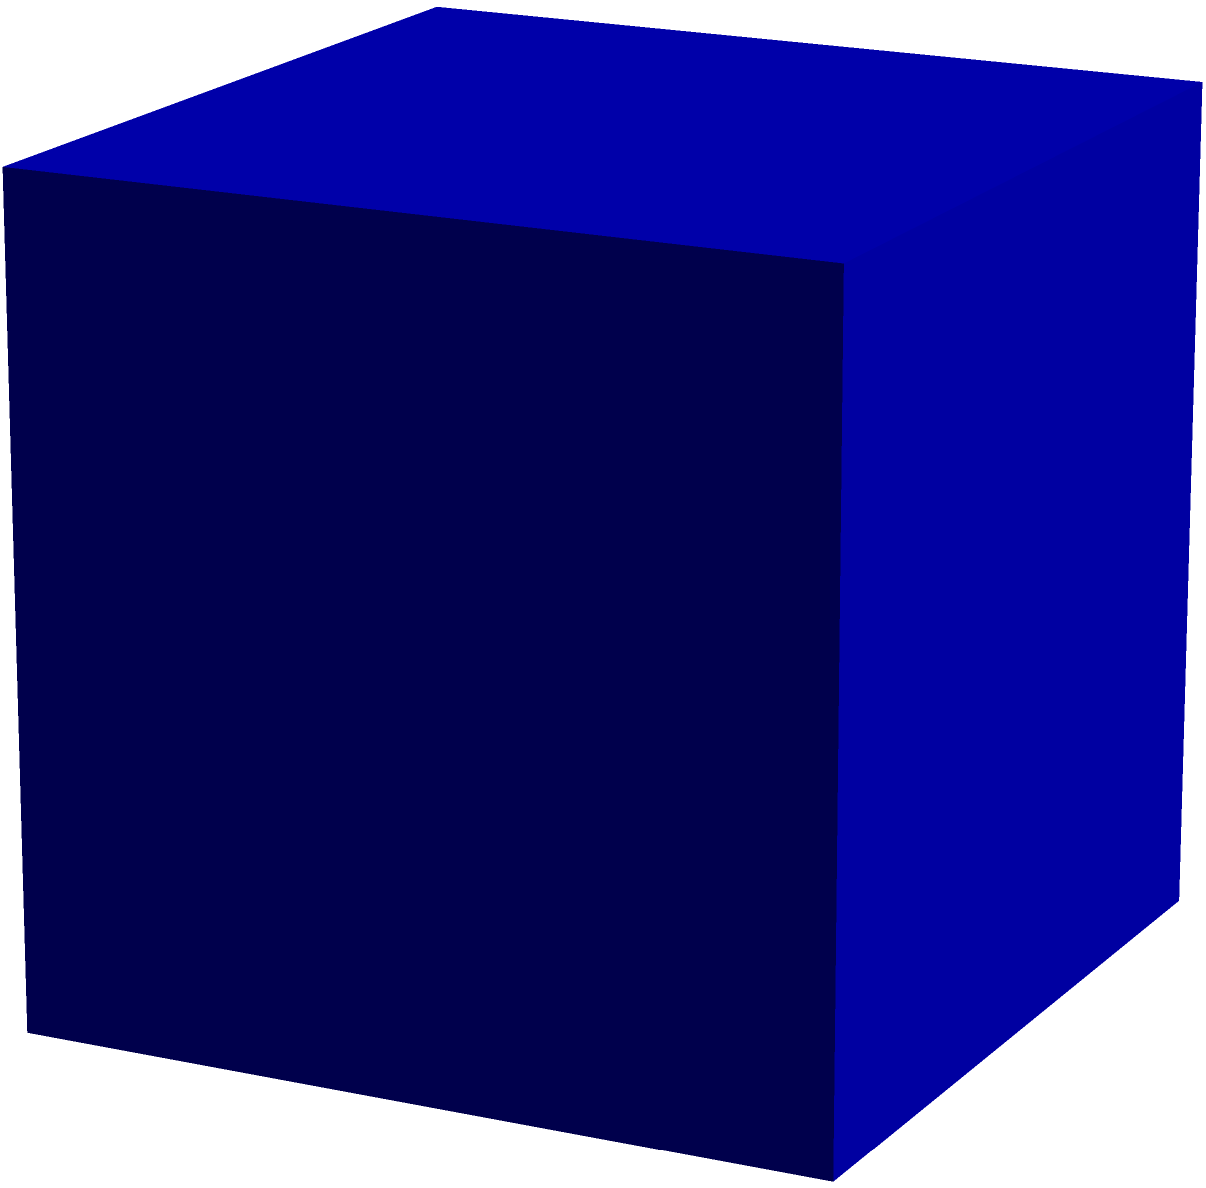The government is planning to construct a new public building in the shape of a cube. If the side length of this building is 50 meters, what would be the total surface area that needs to be covered with special weather-resistant material? Express your answer in square meters. Let's approach this step-by-step:

1) First, recall the formula for the surface area of a cube:
   Surface Area = $6a^2$, where $a$ is the length of one side.

2) We're given that the side length is 50 meters. Let's substitute this into our formula:
   Surface Area = $6 * (50\text{ m})^2$

3) Now, let's calculate:
   Surface Area = $6 * 2500\text{ m}^2$
   
4) Simplify:
   Surface Area = $15000\text{ m}^2$

Therefore, the total surface area that needs to be covered with the special weather-resistant material is 15000 square meters.
Answer: 15000 m² 